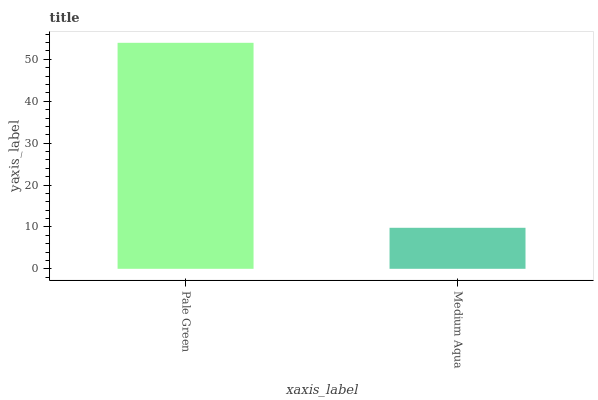Is Medium Aqua the minimum?
Answer yes or no. Yes. Is Pale Green the maximum?
Answer yes or no. Yes. Is Medium Aqua the maximum?
Answer yes or no. No. Is Pale Green greater than Medium Aqua?
Answer yes or no. Yes. Is Medium Aqua less than Pale Green?
Answer yes or no. Yes. Is Medium Aqua greater than Pale Green?
Answer yes or no. No. Is Pale Green less than Medium Aqua?
Answer yes or no. No. Is Pale Green the high median?
Answer yes or no. Yes. Is Medium Aqua the low median?
Answer yes or no. Yes. Is Medium Aqua the high median?
Answer yes or no. No. Is Pale Green the low median?
Answer yes or no. No. 